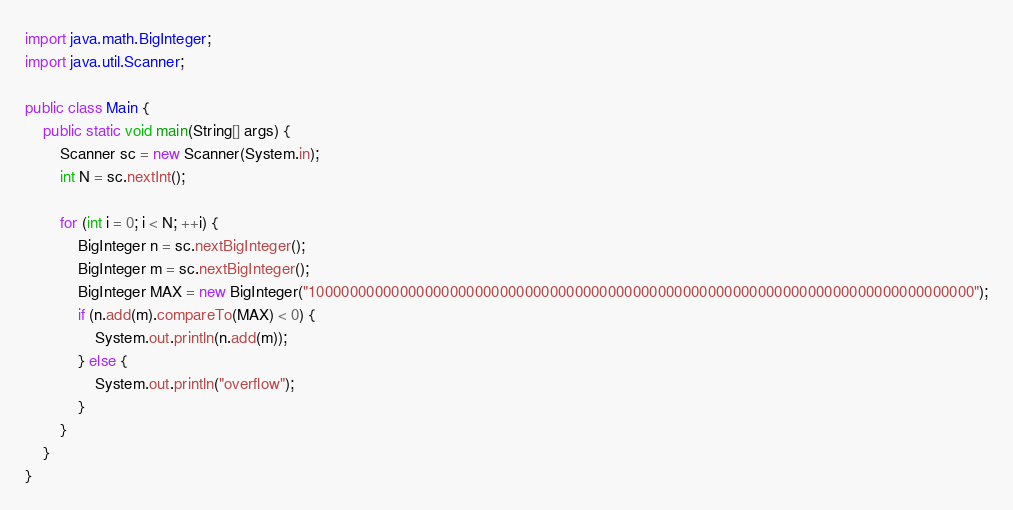<code> <loc_0><loc_0><loc_500><loc_500><_Java_>import java.math.BigInteger;
import java.util.Scanner;

public class Main {
	public static void main(String[] args) {
		Scanner sc = new Scanner(System.in);
		int N = sc.nextInt();
		
		for (int i = 0; i < N; ++i) {		
			BigInteger n = sc.nextBigInteger();
			BigInteger m = sc.nextBigInteger();
			BigInteger MAX = new BigInteger("10000000000000000000000000000000000000000000000000000000000000000000000000000000");
			if (n.add(m).compareTo(MAX) < 0) {
				System.out.println(n.add(m));
			} else {
				System.out.println("overflow");
			}
		}
	}
}</code> 